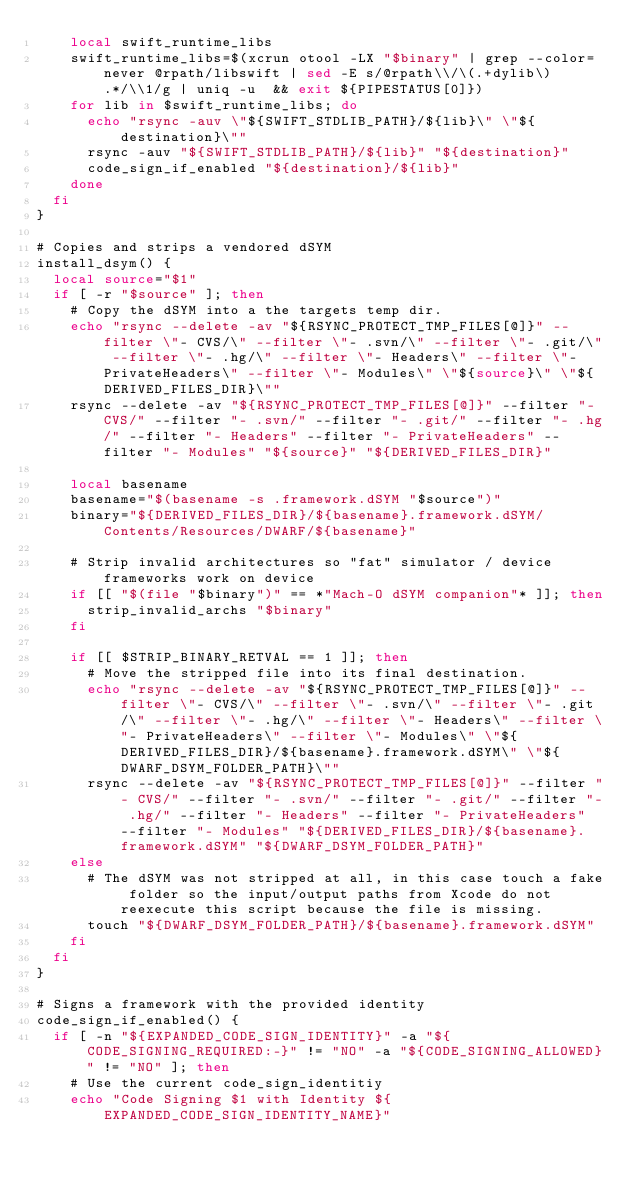<code> <loc_0><loc_0><loc_500><loc_500><_Bash_>    local swift_runtime_libs
    swift_runtime_libs=$(xcrun otool -LX "$binary" | grep --color=never @rpath/libswift | sed -E s/@rpath\\/\(.+dylib\).*/\\1/g | uniq -u  && exit ${PIPESTATUS[0]})
    for lib in $swift_runtime_libs; do
      echo "rsync -auv \"${SWIFT_STDLIB_PATH}/${lib}\" \"${destination}\""
      rsync -auv "${SWIFT_STDLIB_PATH}/${lib}" "${destination}"
      code_sign_if_enabled "${destination}/${lib}"
    done
  fi
}

# Copies and strips a vendored dSYM
install_dsym() {
  local source="$1"
  if [ -r "$source" ]; then
    # Copy the dSYM into a the targets temp dir.
    echo "rsync --delete -av "${RSYNC_PROTECT_TMP_FILES[@]}" --filter \"- CVS/\" --filter \"- .svn/\" --filter \"- .git/\" --filter \"- .hg/\" --filter \"- Headers\" --filter \"- PrivateHeaders\" --filter \"- Modules\" \"${source}\" \"${DERIVED_FILES_DIR}\""
    rsync --delete -av "${RSYNC_PROTECT_TMP_FILES[@]}" --filter "- CVS/" --filter "- .svn/" --filter "- .git/" --filter "- .hg/" --filter "- Headers" --filter "- PrivateHeaders" --filter "- Modules" "${source}" "${DERIVED_FILES_DIR}"

    local basename
    basename="$(basename -s .framework.dSYM "$source")"
    binary="${DERIVED_FILES_DIR}/${basename}.framework.dSYM/Contents/Resources/DWARF/${basename}"

    # Strip invalid architectures so "fat" simulator / device frameworks work on device
    if [[ "$(file "$binary")" == *"Mach-O dSYM companion"* ]]; then
      strip_invalid_archs "$binary"
    fi

    if [[ $STRIP_BINARY_RETVAL == 1 ]]; then
      # Move the stripped file into its final destination.
      echo "rsync --delete -av "${RSYNC_PROTECT_TMP_FILES[@]}" --filter \"- CVS/\" --filter \"- .svn/\" --filter \"- .git/\" --filter \"- .hg/\" --filter \"- Headers\" --filter \"- PrivateHeaders\" --filter \"- Modules\" \"${DERIVED_FILES_DIR}/${basename}.framework.dSYM\" \"${DWARF_DSYM_FOLDER_PATH}\""
      rsync --delete -av "${RSYNC_PROTECT_TMP_FILES[@]}" --filter "- CVS/" --filter "- .svn/" --filter "- .git/" --filter "- .hg/" --filter "- Headers" --filter "- PrivateHeaders" --filter "- Modules" "${DERIVED_FILES_DIR}/${basename}.framework.dSYM" "${DWARF_DSYM_FOLDER_PATH}"
    else
      # The dSYM was not stripped at all, in this case touch a fake folder so the input/output paths from Xcode do not reexecute this script because the file is missing.
      touch "${DWARF_DSYM_FOLDER_PATH}/${basename}.framework.dSYM"
    fi
  fi
}

# Signs a framework with the provided identity
code_sign_if_enabled() {
  if [ -n "${EXPANDED_CODE_SIGN_IDENTITY}" -a "${CODE_SIGNING_REQUIRED:-}" != "NO" -a "${CODE_SIGNING_ALLOWED}" != "NO" ]; then
    # Use the current code_sign_identitiy
    echo "Code Signing $1 with Identity ${EXPANDED_CODE_SIGN_IDENTITY_NAME}"</code> 